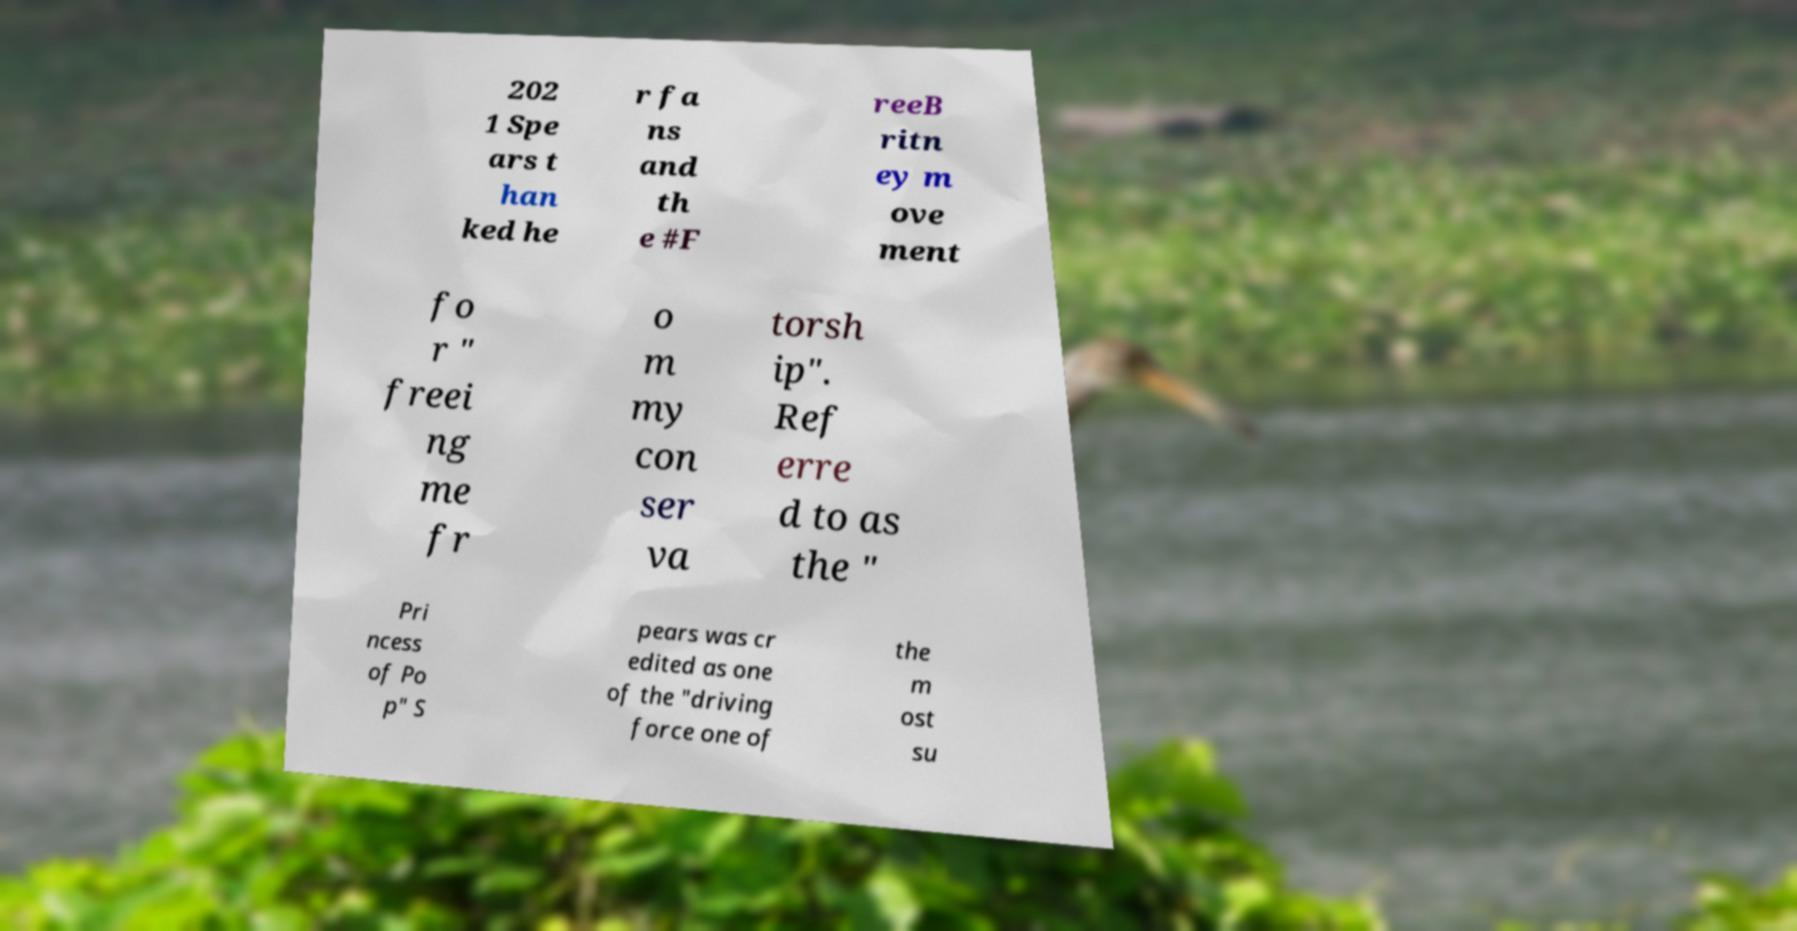Could you extract and type out the text from this image? 202 1 Spe ars t han ked he r fa ns and th e #F reeB ritn ey m ove ment fo r " freei ng me fr o m my con ser va torsh ip". Ref erre d to as the " Pri ncess of Po p" S pears was cr edited as one of the "driving force one of the m ost su 